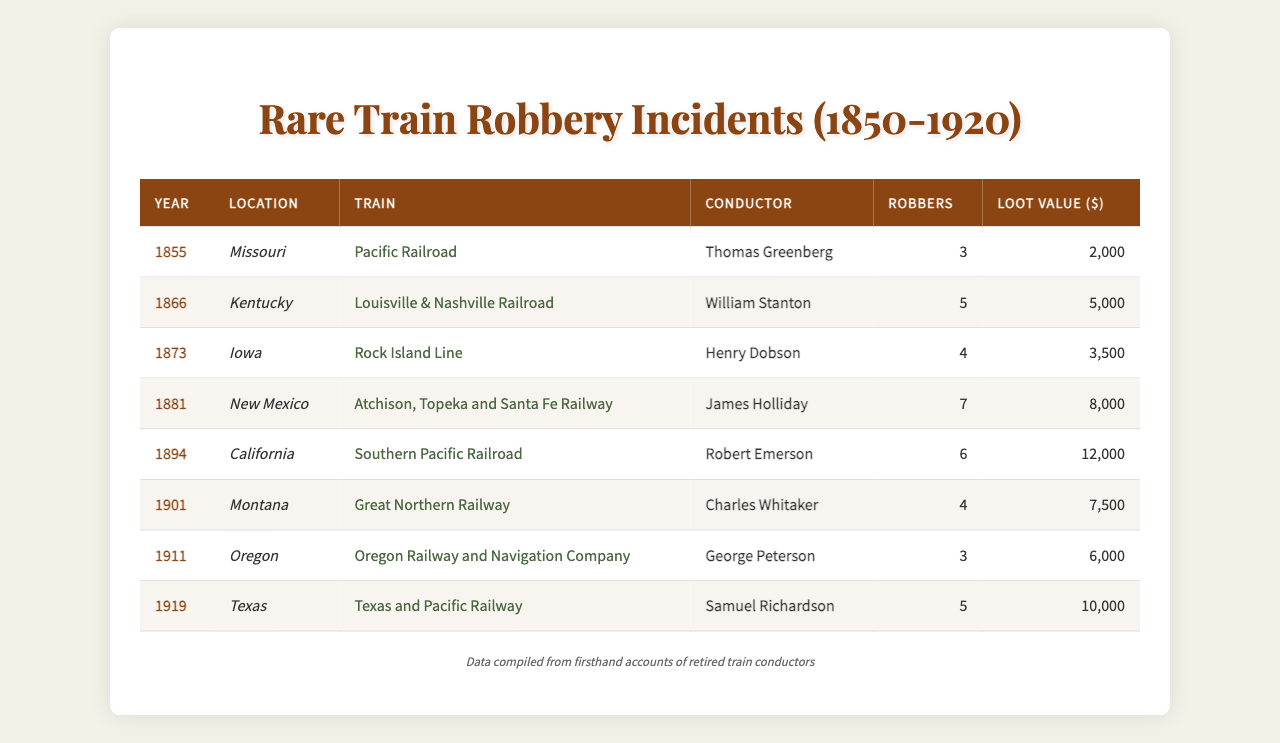What year did the robbery involving the most robbers occur? The incident with the most robbers took place in 1881 when 7 robbers were involved.
Answer: 1881 What was the total loot value from all train robberies in the table? The sum of the loot values is 2000 + 5000 + 3500 + 8000 + 12000 + 7500 + 6000 + 10000 = 40000.
Answer: 40000 Which train had the highest loot value reported? The train with the highest loot value was the Southern Pacific Railroad in 1894, with a loot value of 12000.
Answer: Southern Pacific Railroad Was there an incident reported in the year 1901? Yes, there is an incident recorded in 1901.
Answer: Yes How many robberies had a loot value of more than 5000? There were 5 incidents with a loot value greater than 5000: 8000, 12000, 7500, 6000, and 10000.
Answer: 5 What is the average number of robbers across all incidents? The total number of robbers is 3 + 5 + 4 + 7 + 6 + 4 + 3 + 5 = 37. There are 8 incidents, so the average is 37/8 = 4.625.
Answer: 4.625 In which location was the robbery with the lowest loot value reported? The lowest loot value of 2000 was reported in Missouri in 1855.
Answer: Missouri Did more than half of the robberies involve over 4 robbers? Yes, 5 out of 8 incidents involved more than 4 robbers, which is more than half.
Answer: Yes What was the difference in loot value between the highest and lowest incidents? The highest loot value is 12000 and the lowest is 2000. The difference is 12000 - 2000 = 10000.
Answer: 10000 Which conductor was involved in the train robbery with the second highest loot value? The second highest loot value of 10000 was associated with conductor Samuel Richardson in 1919.
Answer: Samuel Richardson 